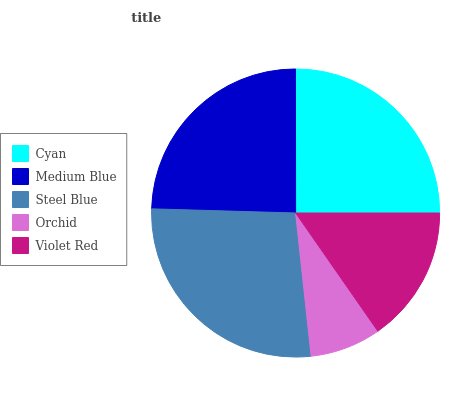Is Orchid the minimum?
Answer yes or no. Yes. Is Steel Blue the maximum?
Answer yes or no. Yes. Is Medium Blue the minimum?
Answer yes or no. No. Is Medium Blue the maximum?
Answer yes or no. No. Is Cyan greater than Medium Blue?
Answer yes or no. Yes. Is Medium Blue less than Cyan?
Answer yes or no. Yes. Is Medium Blue greater than Cyan?
Answer yes or no. No. Is Cyan less than Medium Blue?
Answer yes or no. No. Is Medium Blue the high median?
Answer yes or no. Yes. Is Medium Blue the low median?
Answer yes or no. Yes. Is Cyan the high median?
Answer yes or no. No. Is Steel Blue the low median?
Answer yes or no. No. 